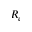Convert formula to latex. <formula><loc_0><loc_0><loc_500><loc_500>R _ { e }</formula> 